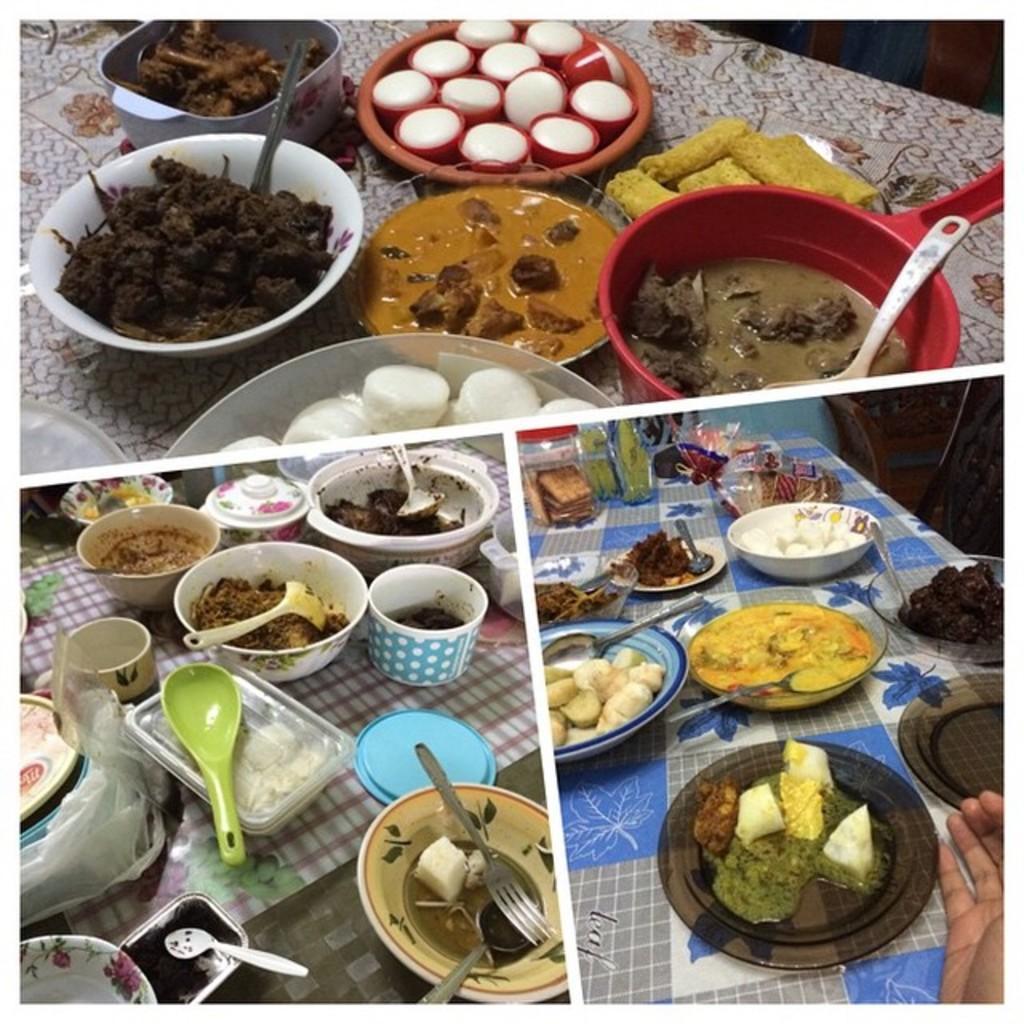Please provide a concise description of this image. This is a collage image. In this image we can see different kinds of food items placed in the serving dishes, cutlery and crockery. 